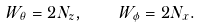<formula> <loc_0><loc_0><loc_500><loc_500>W _ { \theta } = 2 N _ { z } , \quad W _ { \phi } = 2 N _ { x } .</formula> 